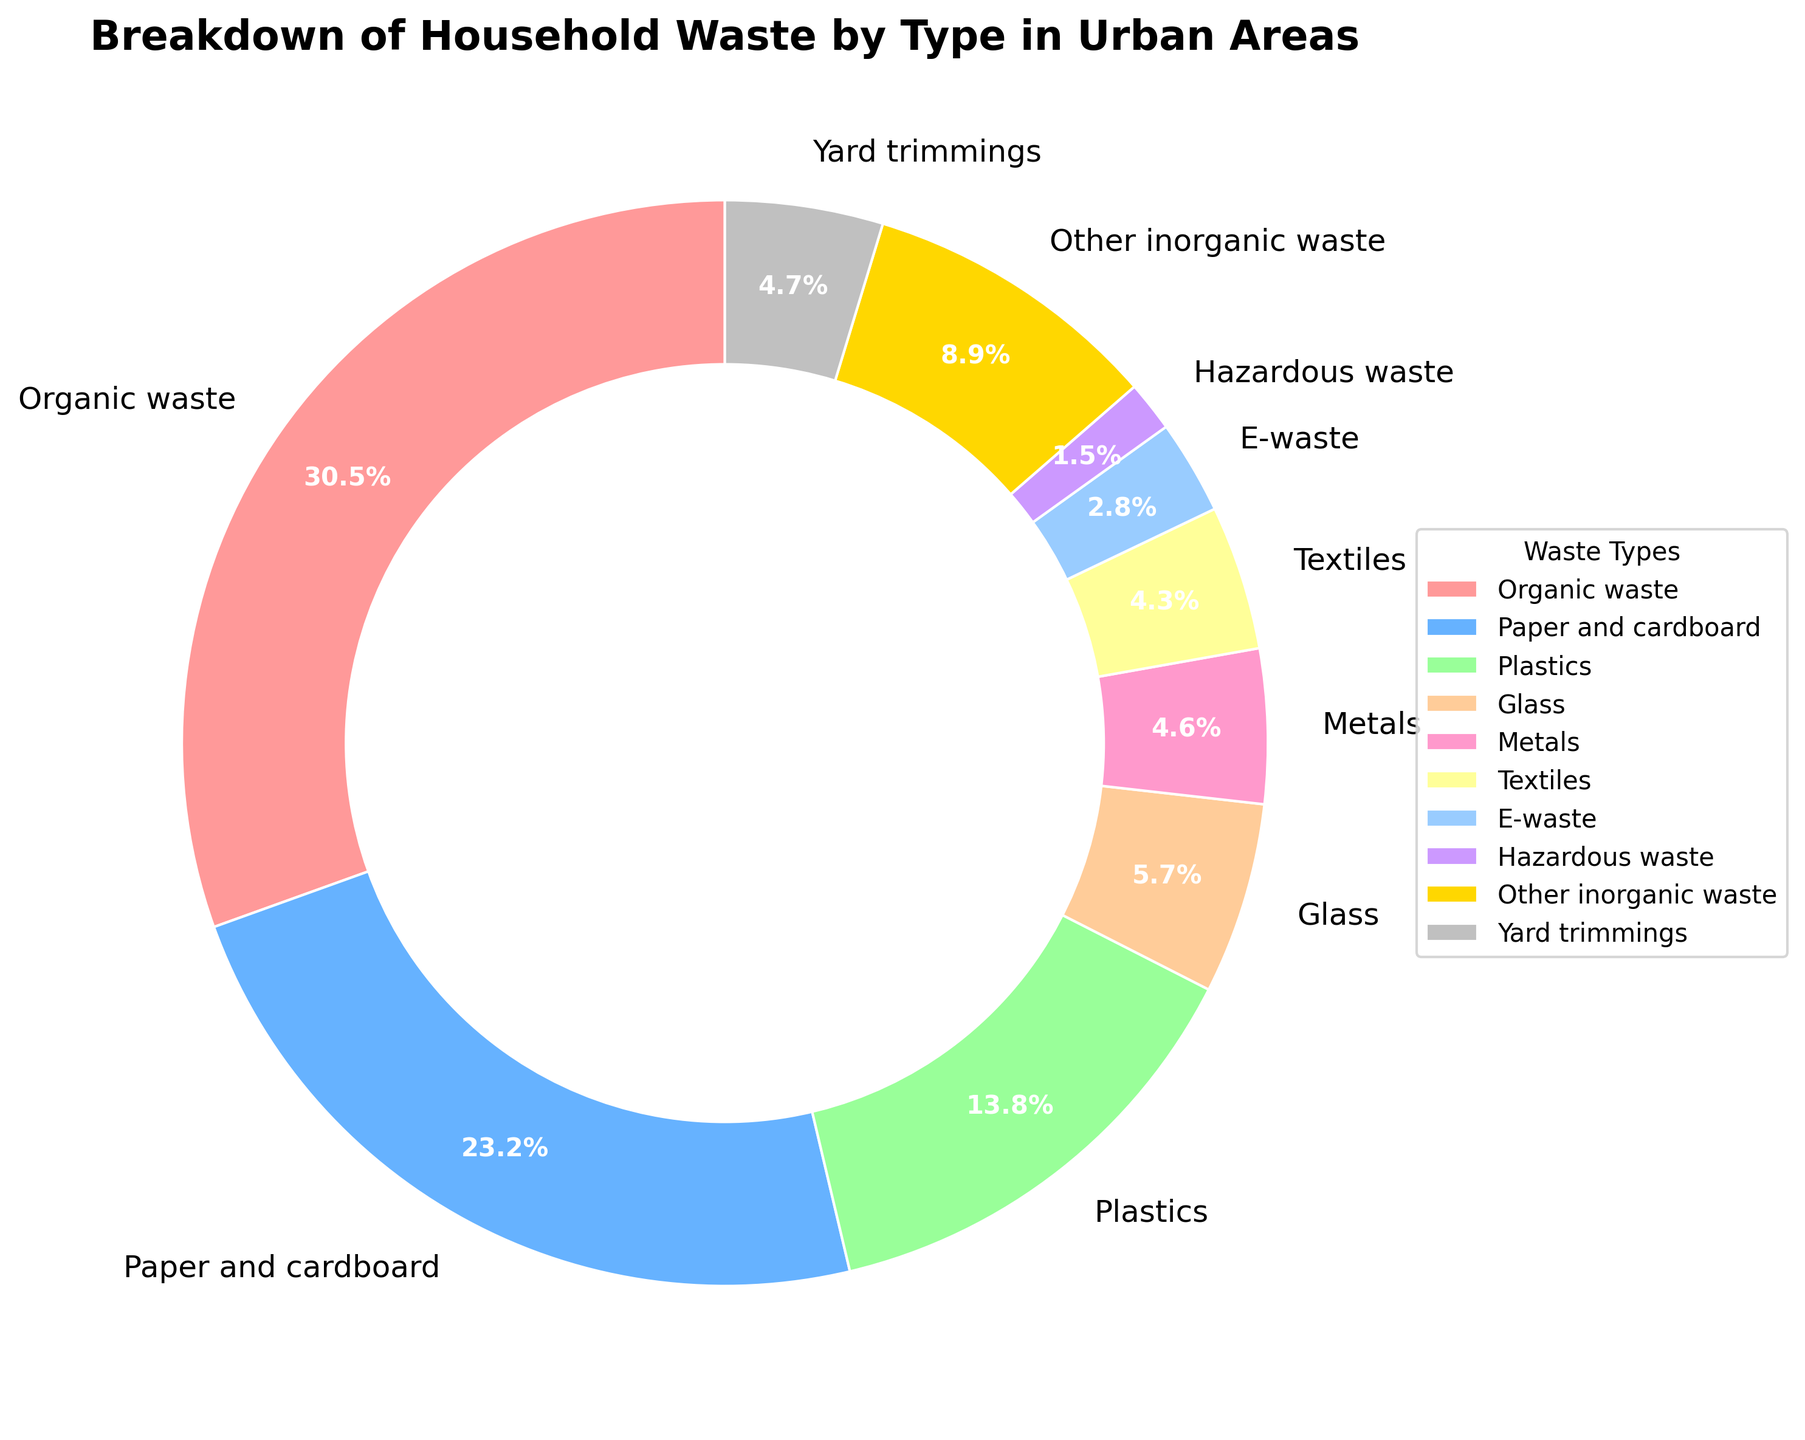What is the largest category of household waste in urban areas? The figure shows that the largest portion of the pie chart is "Organic waste," with a percentage of 30.5%.
Answer: Organic waste How much larger is the percentage of paper and cardboard waste compared to plastic waste? The percentage of paper and cardboard waste is 23.2%, while the percentage of plastic waste is 13.8%. The difference is thus 23.2% - 13.8%.
Answer: 9.4% Which waste categories make up less than 5% of the total household waste each? According to the pie chart, categories including Glass (5.7%), Yard trimmings (4.7%), Metals (4.6%), Textiles (4.3%), E-waste (2.8%), and Hazardous waste (1.5%) comprise less than 5% of the total household waste each. We exclude Glass and Yard trimmings since they are slightly above 5%.
Answer: Metals, Textiles, E-waste, Hazardous waste What is the combined percentage of e-waste and hazardous waste? The percentages for e-waste and hazardous waste are 2.8% and 1.5%, respectively. The combined percentage is 2.8% + 1.5%.
Answer: 4.3% Which category has a higher percentage: textiles or metals? From the pie chart, textiles have a percentage of 4.3% and metals have a percentage of 4.6%. Therefore, metals have a higher percentage.
Answer: Metals What is the total percentage of inorganic waste categories including glass, metals, and other inorganic waste? According to the chart, the percentages are as follows: Glass (5.7%), Metals (4.6%), Other inorganic waste (8.9%). Adding these gives 5.7% + 4.6% + 8.9%.
Answer: 19.2% What color corresponds to the 'Texts and Cardboard' section in the pie chart? The pie chart uses various colors for different categories. The 'Paper and Cardboard' section is colored with a shade that stands out, specifically '#66B2FF,' a shade of blue.
Answer: Blue Among hazardous waste and other inorganic waste, which one occupies more space in the pie chart? The pie chart shows that hazardous waste is 1.5%, and other inorganic waste is 8.9%, which means other inorganic waste occupies more space.
Answer: Other inorganic waste What is the difference between the percentage of organic waste and paper and cardboard waste? Organic waste is 30.5%, and paper and cardboard waste is 23.2%. The difference is thus 30.5% - 23.2%.
Answer: 7.3% How does the percentage of yard trimmings compare visually to textiles? Both categories are below 5% but the pie chart shows yard trimmings as being slightly larger, specifically 4.7% compared to 4.3% for textiles.
Answer: Yard trimmings is slightly larger 